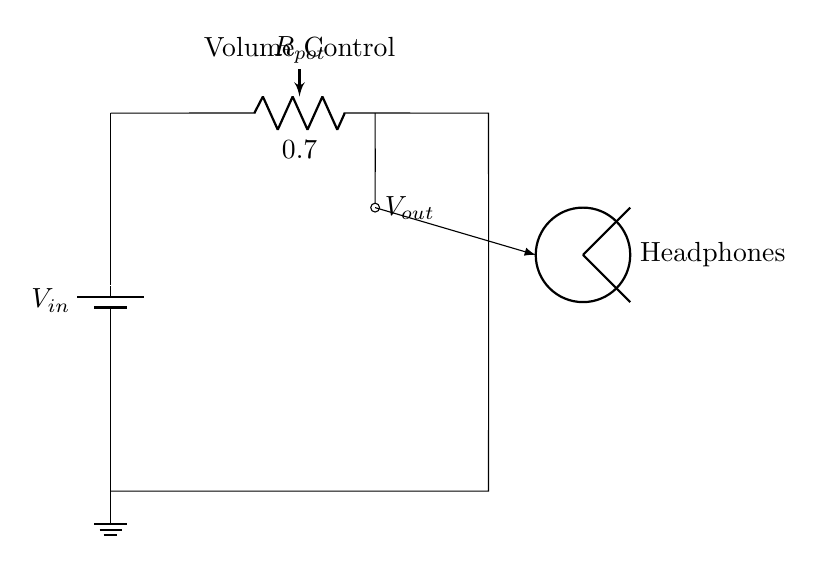What is the input voltage of the circuit? The circuit shows a battery labeled V_{in}, which represents the input voltage applied across the potentiometer. Since there's no value specified, we refer to it as V_{in}.
Answer: V_{in} What is the output voltage labeled in the diagram? The output voltage is indicated as V_{out} which is taken from the middle terminal of the potentiometer connected to the headphones.
Answer: V_{out} What type of circuit is represented? The circuit is a voltage divider as it uses a potentiometer to divide the input voltage into a lower output voltage for adjusting volume.
Answer: Voltage divider What is the function of the potentiometer in this circuit? The potentiometer acts as a variable resistor that adjusts the voltage level (volume) sent to the headphones by changing the division of voltage at its terminals.
Answer: Volume control How does changing the potentiometer affect the output? Altering the resistance of the potentiometer changes the ratio of V_{in} across its terminals, resulting in a higher or lower V_{out} depending on the direction of adjustment.
Answer: Changes V_{out} What happens when the potentiometer is turned to its maximum? When turned to maximum resistance, the circuit will output the maximum possible voltage (close to V_{in}) to the headphones, resulting in the highest volume.
Answer: Maximum volume What happens when the potentiometer is turned to its minimum? At minimum resistance, most of the voltage is dropped across the potentiometer, resulting in a minimal V_{out} that delivers the lowest volume to the headphones.
Answer: Minimum volume 